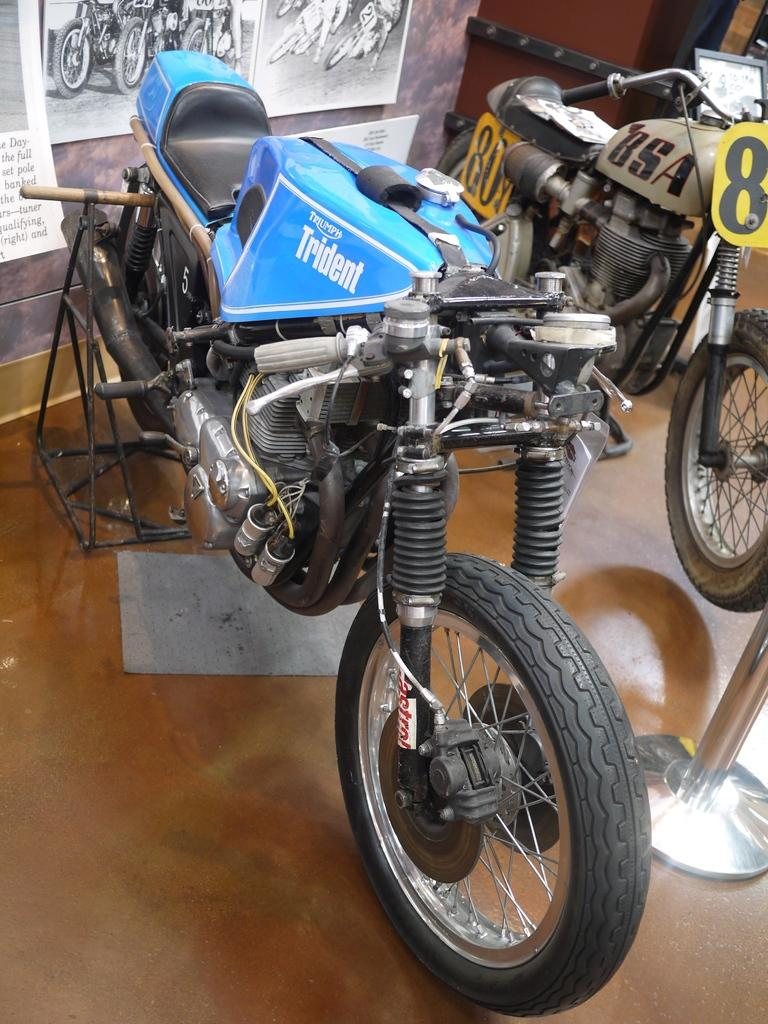What type of vehicles are in the image? There are bikes in the image. How are the bikes positioned in the image? The bikes are on a stand on the floor. What can be seen on the wall behind the bikes? There are posts on a wall behind the bikes. How does the fog affect the visibility of the bikes in the image? There is no fog present in the image, so it does not affect the visibility of the bikes. 